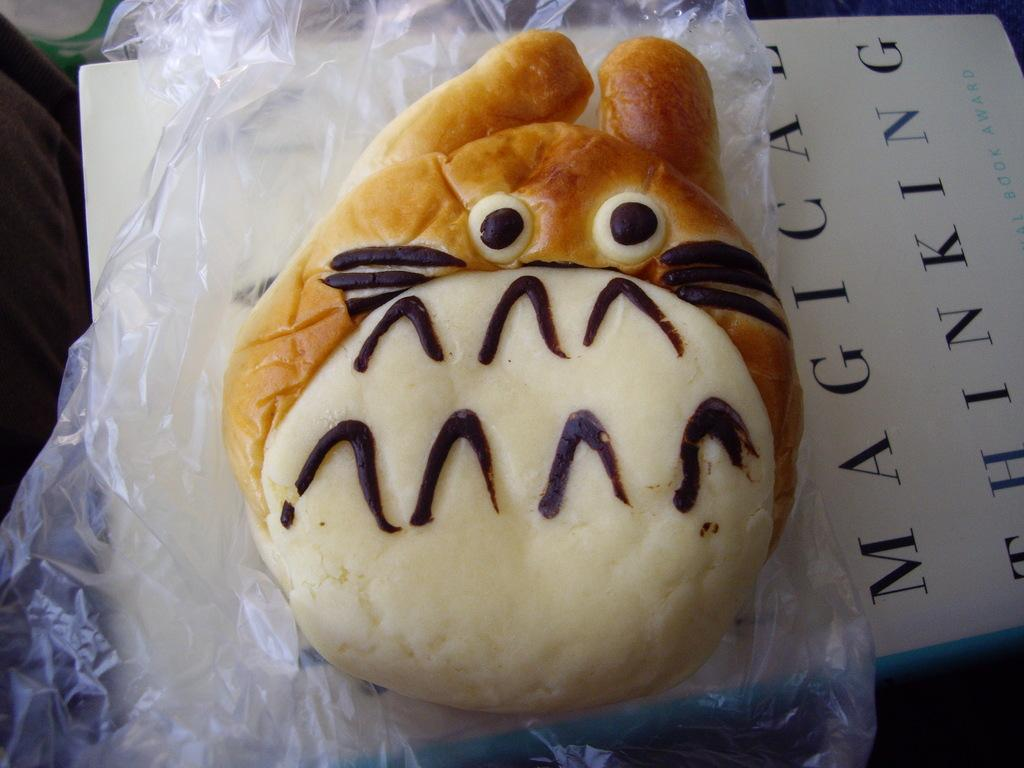What type of food item can be seen in the image? There is a baked food item in the image. How is the baked food item being presented? The baked food item is on a cover. What is the color of the paper beneath the cover? The cover is on a white color paper. Can you see the view from the iron in the image? There is no iron present in the image, and therefore no view can be seen from it. 